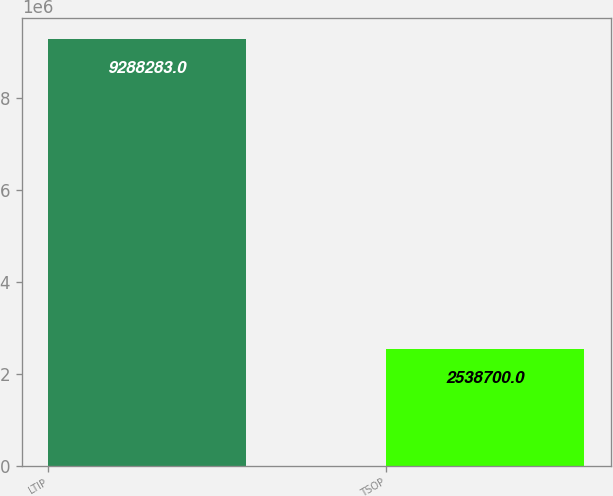Convert chart. <chart><loc_0><loc_0><loc_500><loc_500><bar_chart><fcel>LTIP<fcel>TSOP<nl><fcel>9.28828e+06<fcel>2.5387e+06<nl></chart> 